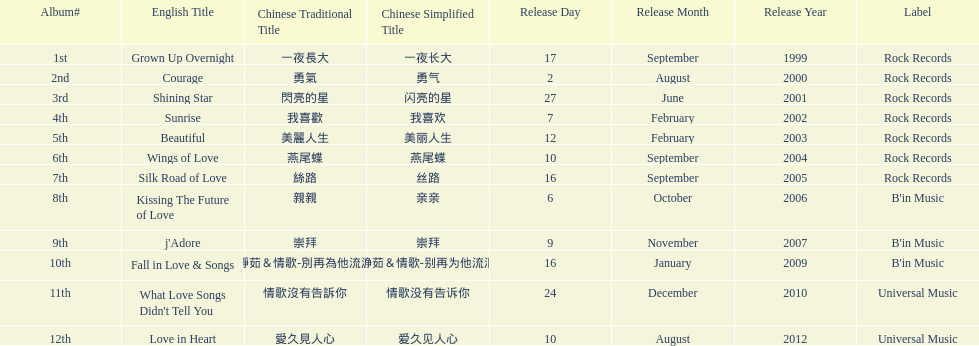What is the number of songs on rock records? 7. 